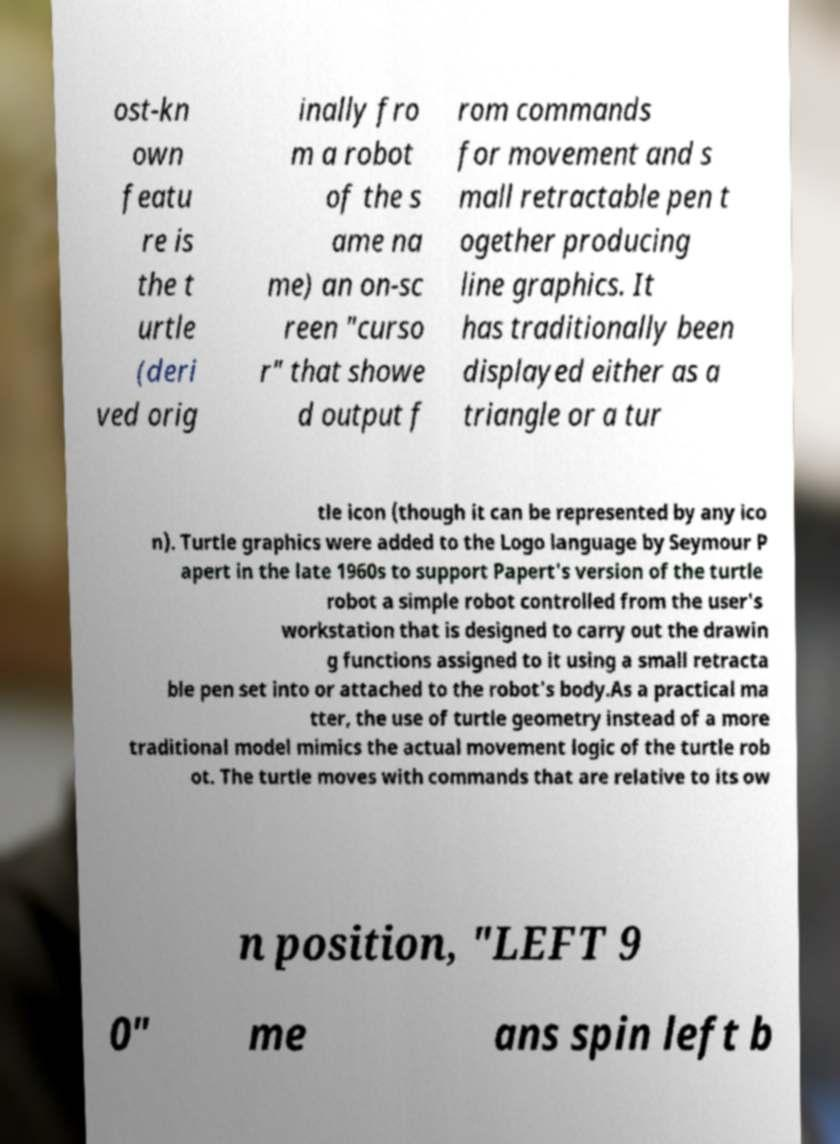I need the written content from this picture converted into text. Can you do that? ost-kn own featu re is the t urtle (deri ved orig inally fro m a robot of the s ame na me) an on-sc reen "curso r" that showe d output f rom commands for movement and s mall retractable pen t ogether producing line graphics. It has traditionally been displayed either as a triangle or a tur tle icon (though it can be represented by any ico n). Turtle graphics were added to the Logo language by Seymour P apert in the late 1960s to support Papert's version of the turtle robot a simple robot controlled from the user's workstation that is designed to carry out the drawin g functions assigned to it using a small retracta ble pen set into or attached to the robot's body.As a practical ma tter, the use of turtle geometry instead of a more traditional model mimics the actual movement logic of the turtle rob ot. The turtle moves with commands that are relative to its ow n position, "LEFT 9 0" me ans spin left b 